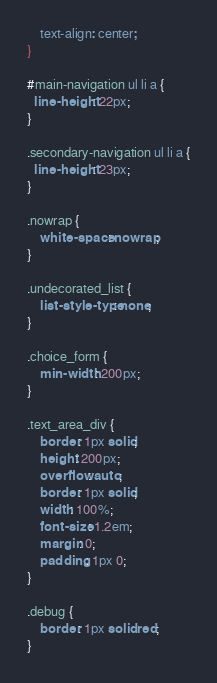Convert code to text. <code><loc_0><loc_0><loc_500><loc_500><_CSS_>    text-align: center;
}

#main-navigation ul li a {
  line-height: 22px;
}

.secondary-navigation ul li a {
  line-height: 23px;
}
 
.nowrap {
    white-space: nowrap;
}

.undecorated_list {
    list-style-type: none;
}

.choice_form {
    min-width: 200px;
}

.text_area_div {
    border: 1px solid;
    height: 200px;
    overflow: auto;
    border: 1px solid;
    width: 100%;
    font-size: 1.2em;
    margin: 0;
    padding: 1px 0;
}

.debug {
    border: 1px solid red;
}
</code> 